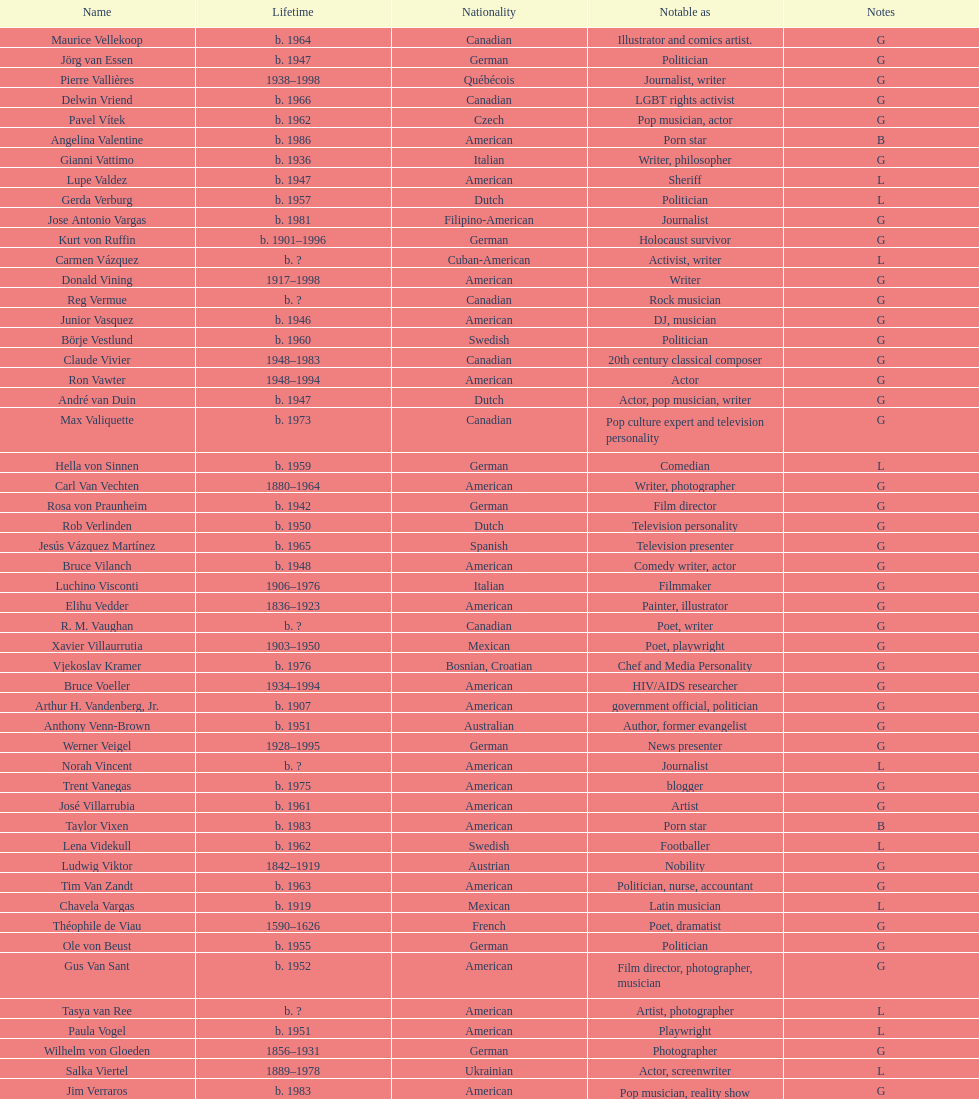Which nationality had the most notable poets? French. 